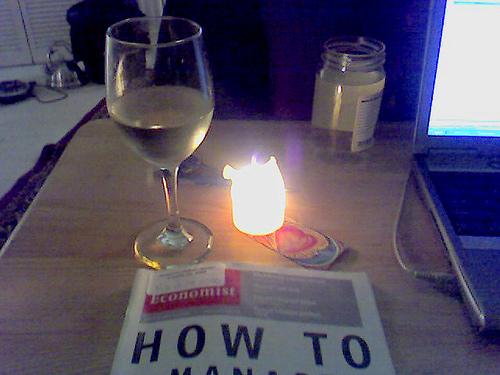What color is the liquid in the glass?
Give a very brief answer. Clear. Does this person need a refill?
Be succinct. No. How many glasses have something in them?
Concise answer only. 1. How many wine glasses are on the table?
Quick response, please. 1. What is on the counter behind the laptop?
Give a very brief answer. Jar. Is there any liquid in the glass?
Be succinct. Yes. What is in the taller glass?
Quick response, please. Wine. How many white wines do you see?
Give a very brief answer. 1. What color is the liquid in the glasses?
Answer briefly. Clear. What liquid is in the glass?
Concise answer only. Wine. Is there a candle burning?
Be succinct. Yes. Is there a lemon in the glass?
Keep it brief. No. 